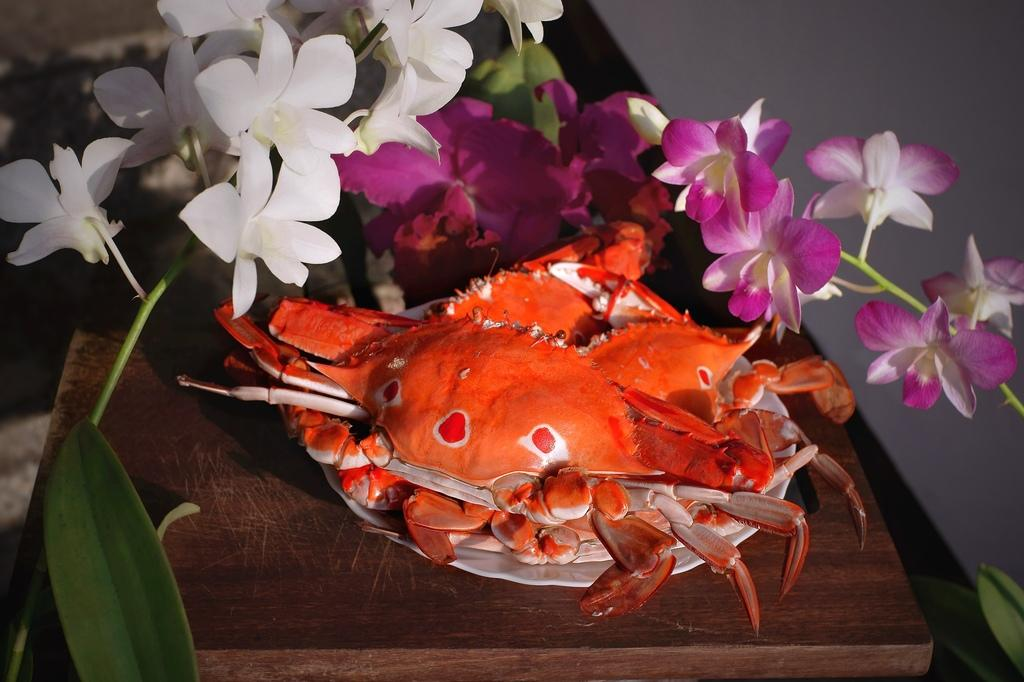What is placed on the plate in the image? There is an object on a plate in the image. What is the object placed on? The plate is on a wooden platform. What type of vegetation is present around the object? There are plants with flowers and leaves around the object. What can be seen in the background of the image? There is a wall visible in the background. How many arguments can be heard taking place in the image? There are no arguments present in the image; it only features an object on a plate, plants, and a wall in the background. 